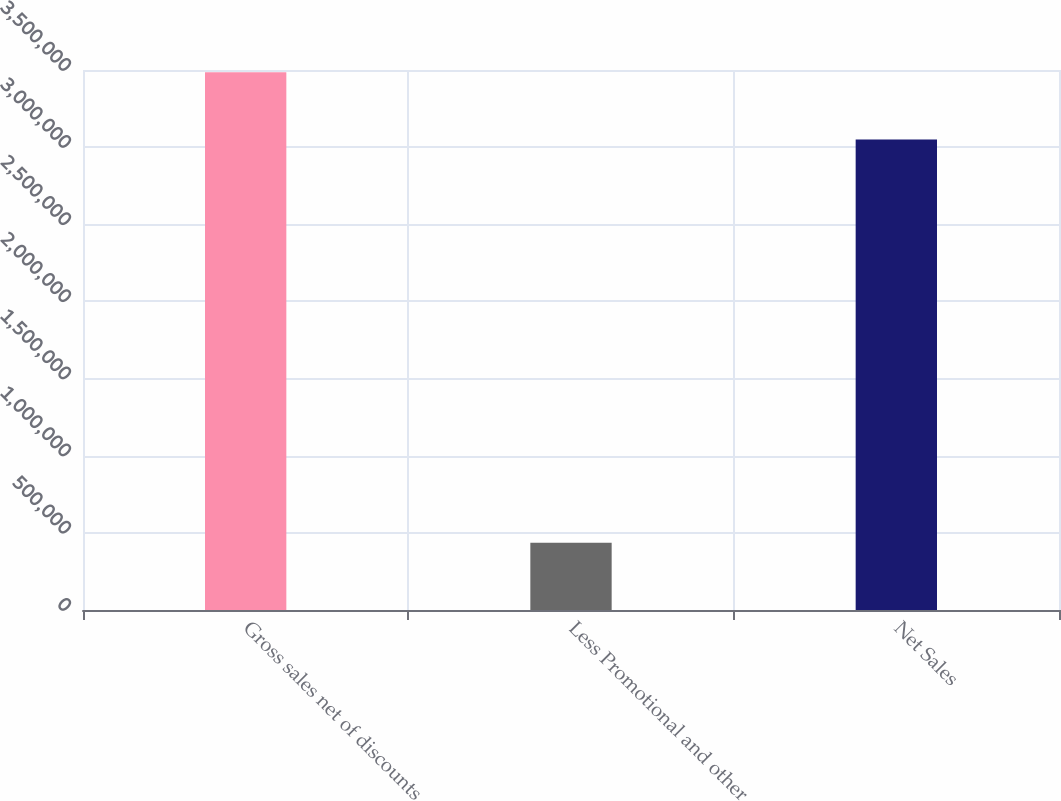Convert chart. <chart><loc_0><loc_0><loc_500><loc_500><bar_chart><fcel>Gross sales net of discounts<fcel>Less Promotional and other<fcel>Net Sales<nl><fcel>3.48546e+06<fcel>436070<fcel>3.04939e+06<nl></chart> 